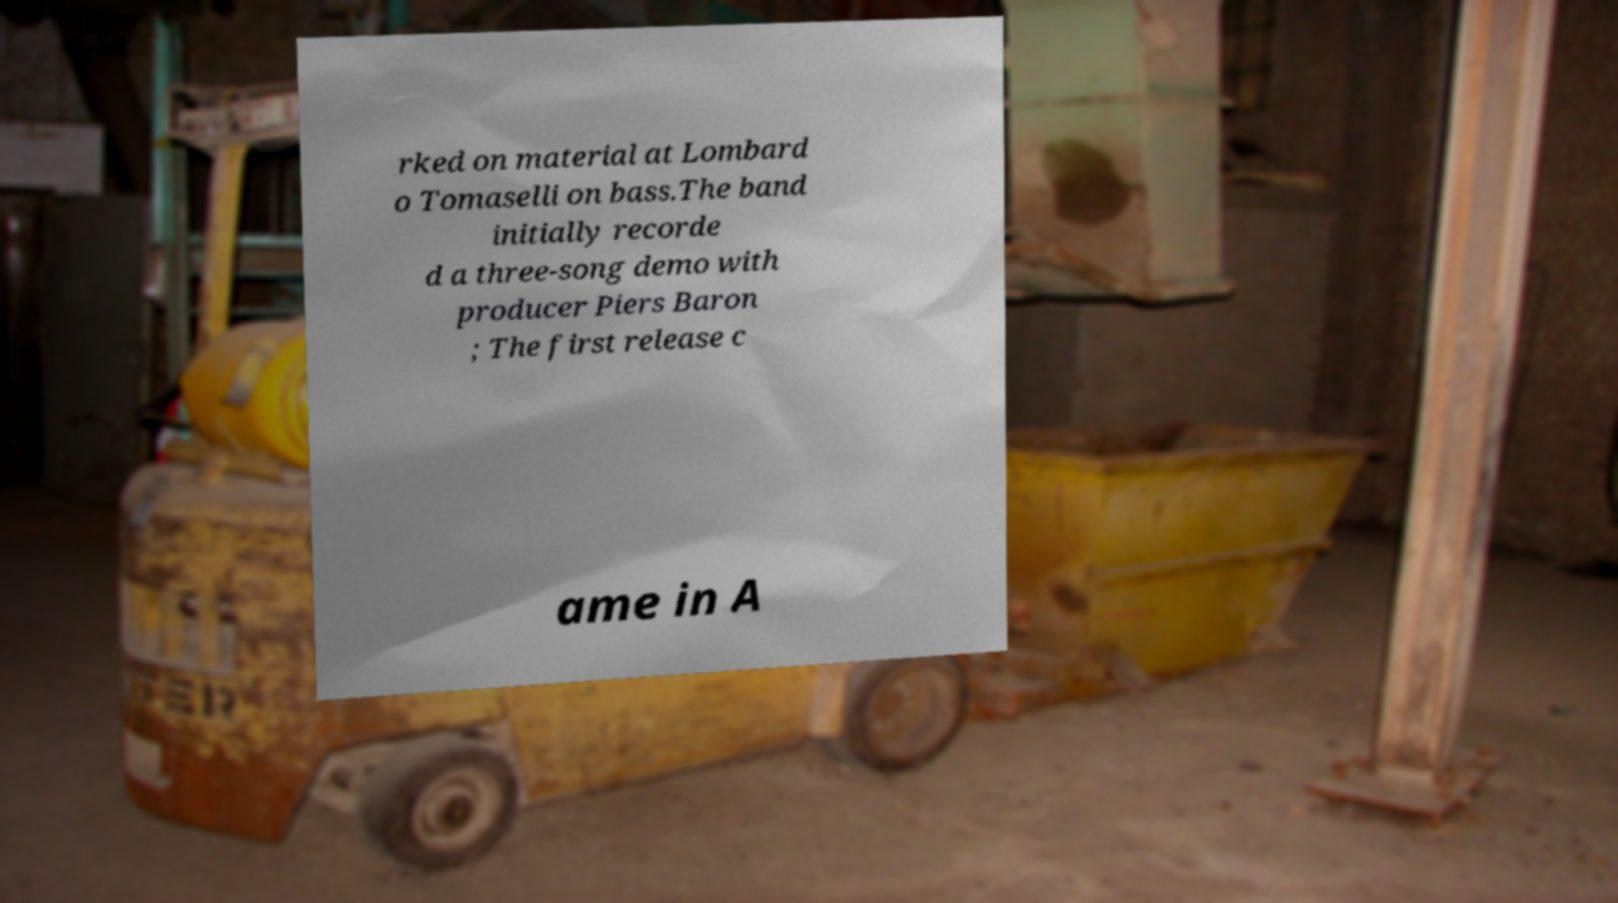For documentation purposes, I need the text within this image transcribed. Could you provide that? rked on material at Lombard o Tomaselli on bass.The band initially recorde d a three-song demo with producer Piers Baron ; The first release c ame in A 